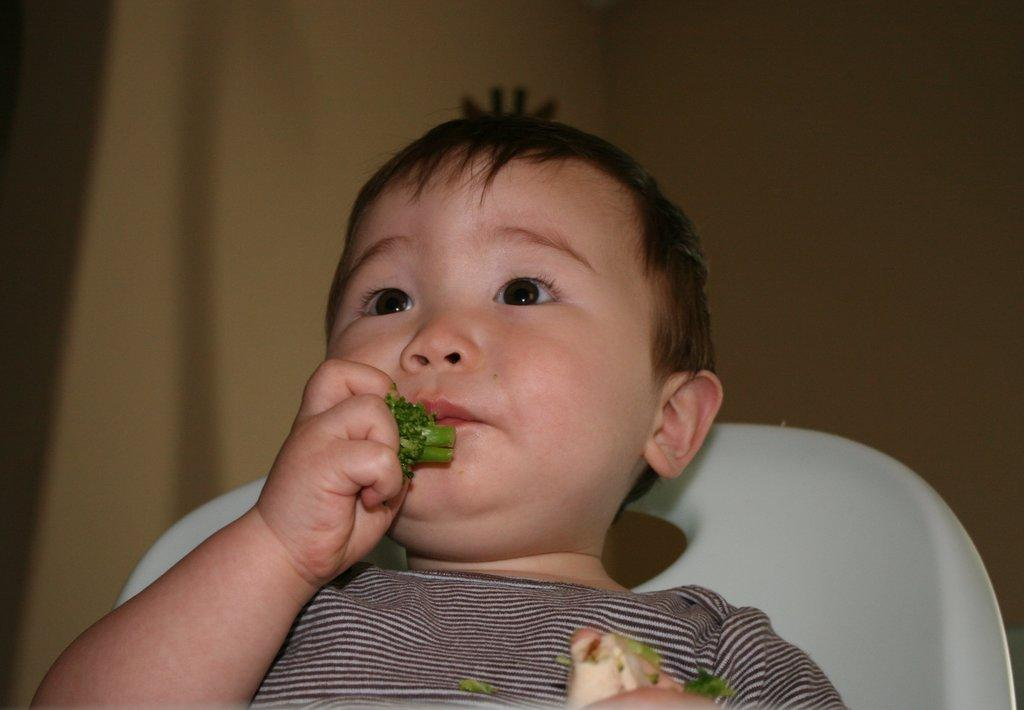What is the main subject of the image? The main subject of the image is a kid. What is the kid doing in the image? The kid is sitting in a chair. What is the kid holding in his hand? The kid is holding a green-colored eatable in his hand. Is the kid participating in a snow feast in the image? There is no mention of snow or a feast in the image; it simply shows a kid sitting in a chair holding a green-colored eatable. 